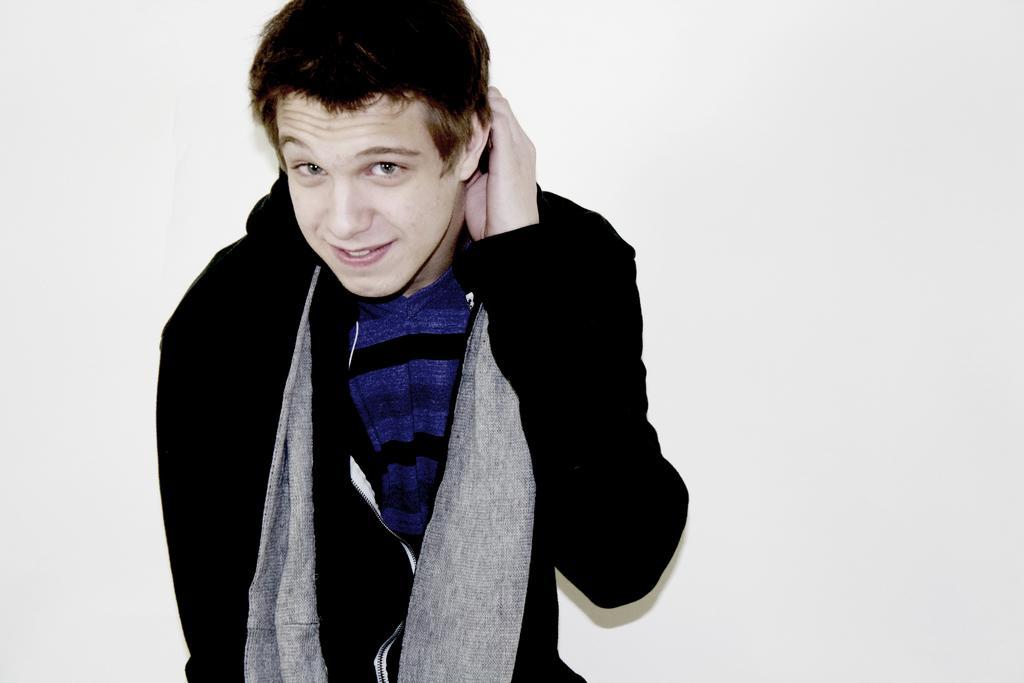How would you summarize this image in a sentence or two? In this image there is a man standing in the center and smiling. 